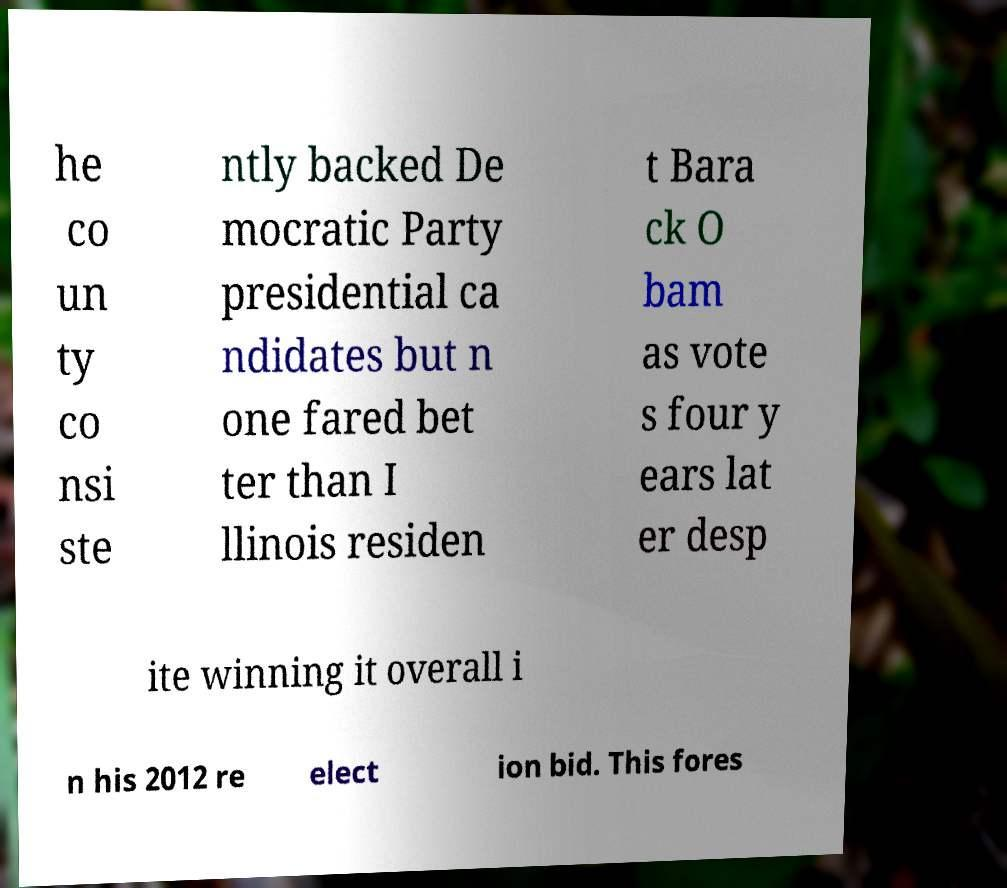Could you assist in decoding the text presented in this image and type it out clearly? he co un ty co nsi ste ntly backed De mocratic Party presidential ca ndidates but n one fared bet ter than I llinois residen t Bara ck O bam as vote s four y ears lat er desp ite winning it overall i n his 2012 re elect ion bid. This fores 